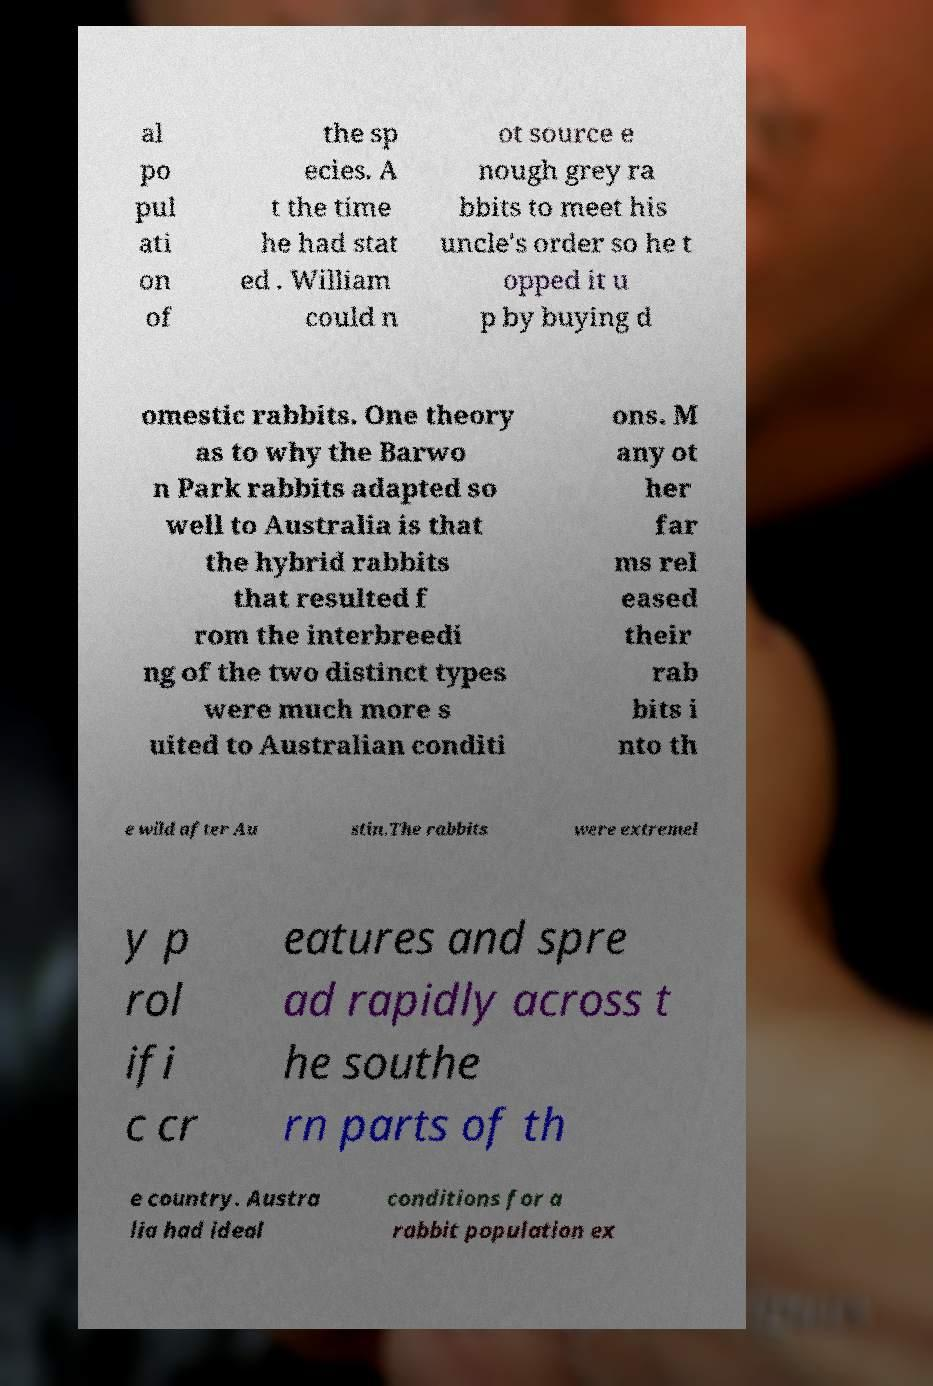Can you accurately transcribe the text from the provided image for me? al po pul ati on of the sp ecies. A t the time he had stat ed . William could n ot source e nough grey ra bbits to meet his uncle's order so he t opped it u p by buying d omestic rabbits. One theory as to why the Barwo n Park rabbits adapted so well to Australia is that the hybrid rabbits that resulted f rom the interbreedi ng of the two distinct types were much more s uited to Australian conditi ons. M any ot her far ms rel eased their rab bits i nto th e wild after Au stin.The rabbits were extremel y p rol ifi c cr eatures and spre ad rapidly across t he southe rn parts of th e country. Austra lia had ideal conditions for a rabbit population ex 